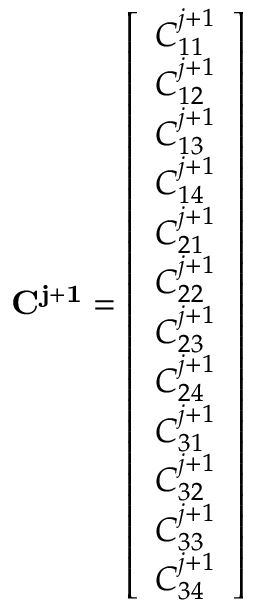Convert formula to latex. <formula><loc_0><loc_0><loc_500><loc_500>C ^ { j + 1 } = { \left [ \begin{array} { l } { C _ { 1 1 } ^ { j + 1 } } \\ { C _ { 1 2 } ^ { j + 1 } } \\ { C _ { 1 3 } ^ { j + 1 } } \\ { C _ { 1 4 } ^ { j + 1 } } \\ { C _ { 2 1 } ^ { j + 1 } } \\ { C _ { 2 2 } ^ { j + 1 } } \\ { C _ { 2 3 } ^ { j + 1 } } \\ { C _ { 2 4 } ^ { j + 1 } } \\ { C _ { 3 1 } ^ { j + 1 } } \\ { C _ { 3 2 } ^ { j + 1 } } \\ { C _ { 3 3 } ^ { j + 1 } } \\ { C _ { 3 4 } ^ { j + 1 } } \end{array} \right ] }</formula> 